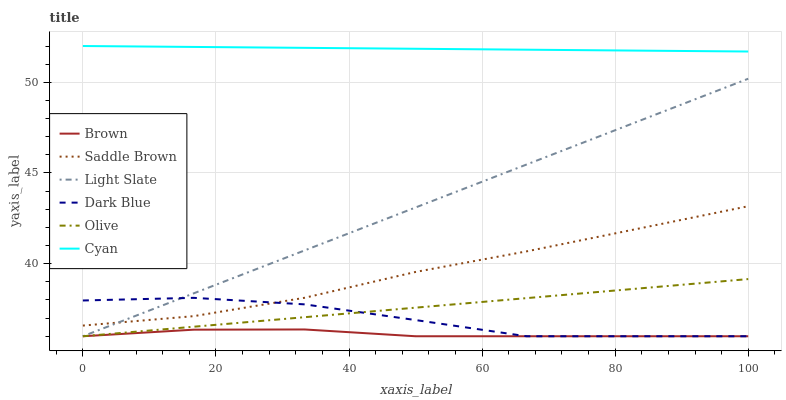Does Brown have the minimum area under the curve?
Answer yes or no. Yes. Does Cyan have the maximum area under the curve?
Answer yes or no. Yes. Does Light Slate have the minimum area under the curve?
Answer yes or no. No. Does Light Slate have the maximum area under the curve?
Answer yes or no. No. Is Olive the smoothest?
Answer yes or no. Yes. Is Dark Blue the roughest?
Answer yes or no. Yes. Is Light Slate the smoothest?
Answer yes or no. No. Is Light Slate the roughest?
Answer yes or no. No. Does Brown have the lowest value?
Answer yes or no. Yes. Does Cyan have the lowest value?
Answer yes or no. No. Does Cyan have the highest value?
Answer yes or no. Yes. Does Light Slate have the highest value?
Answer yes or no. No. Is Saddle Brown less than Cyan?
Answer yes or no. Yes. Is Cyan greater than Light Slate?
Answer yes or no. Yes. Does Dark Blue intersect Saddle Brown?
Answer yes or no. Yes. Is Dark Blue less than Saddle Brown?
Answer yes or no. No. Is Dark Blue greater than Saddle Brown?
Answer yes or no. No. Does Saddle Brown intersect Cyan?
Answer yes or no. No. 